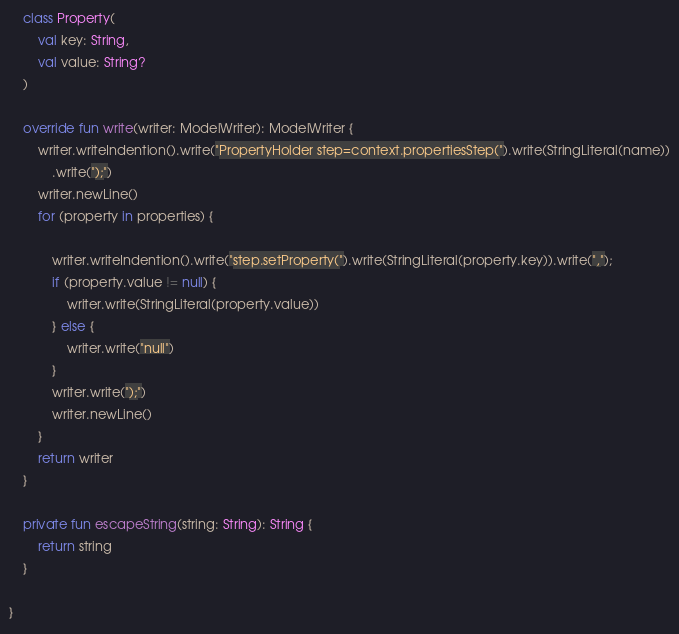Convert code to text. <code><loc_0><loc_0><loc_500><loc_500><_Kotlin_>
    class Property(
        val key: String,
        val value: String?
    )

    override fun write(writer: ModelWriter): ModelWriter {
        writer.writeIndention().write("PropertyHolder step=context.propertiesStep(").write(StringLiteral(name))
            .write(");")
        writer.newLine()
        for (property in properties) {

            writer.writeIndention().write("step.setProperty(").write(StringLiteral(property.key)).write(",");
            if (property.value != null) {
                writer.write(StringLiteral(property.value))
            } else {
                writer.write("null")
            }
            writer.write(");")
            writer.newLine()
        }
        return writer
    }

    private fun escapeString(string: String): String {
        return string
    }

}</code> 